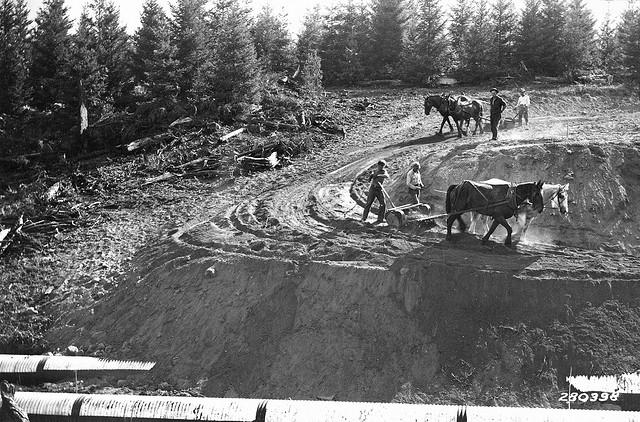How many animals are there?
Quick response, please. 4. Is the picture in color?
Answer briefly. No. Are these animals working?
Keep it brief. Yes. 